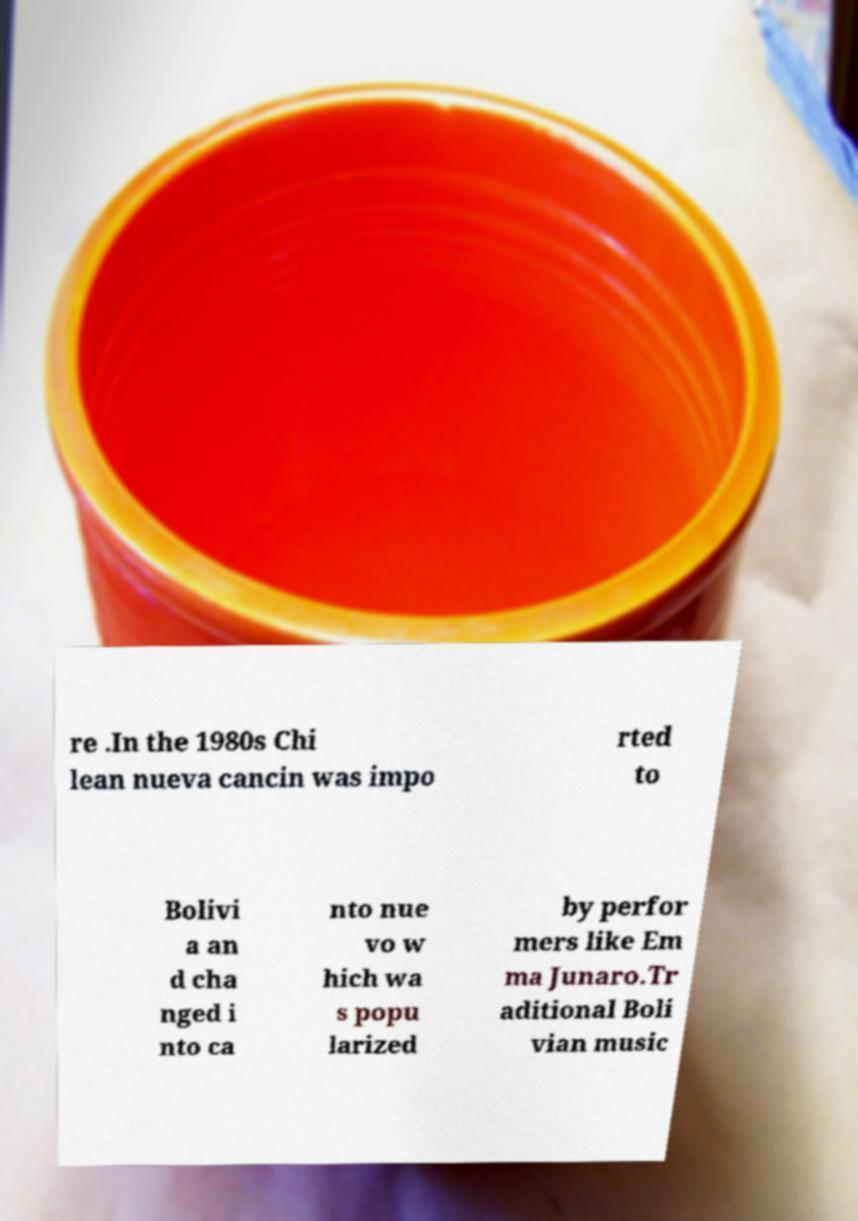I need the written content from this picture converted into text. Can you do that? re .In the 1980s Chi lean nueva cancin was impo rted to Bolivi a an d cha nged i nto ca nto nue vo w hich wa s popu larized by perfor mers like Em ma Junaro.Tr aditional Boli vian music 